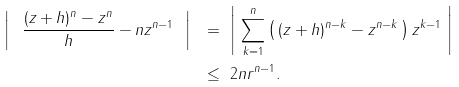<formula> <loc_0><loc_0><loc_500><loc_500>\left | \ \frac { ( z + h ) ^ { n } - z ^ { n } } { h } - n z ^ { n - 1 } \ \right | \ & = \ \left | \ \sum _ { k = 1 } ^ { n } \left ( \, ( z + h ) ^ { n - k } - z ^ { n - k } \, \right ) z ^ { k - 1 } \ \right | \\ \ & \leq \ 2 n r ^ { n - 1 } .</formula> 